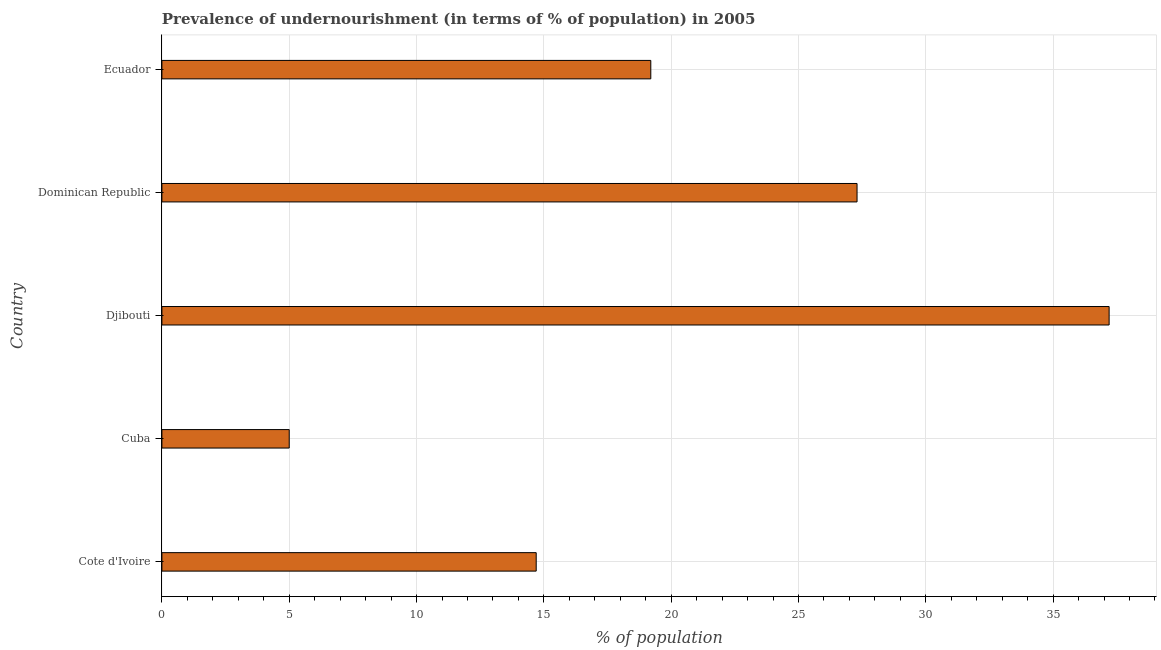Does the graph contain grids?
Provide a short and direct response. Yes. What is the title of the graph?
Keep it short and to the point. Prevalence of undernourishment (in terms of % of population) in 2005. What is the label or title of the X-axis?
Your answer should be compact. % of population. What is the percentage of undernourished population in Ecuador?
Offer a terse response. 19.2. Across all countries, what is the maximum percentage of undernourished population?
Make the answer very short. 37.2. In which country was the percentage of undernourished population maximum?
Provide a short and direct response. Djibouti. In which country was the percentage of undernourished population minimum?
Your response must be concise. Cuba. What is the sum of the percentage of undernourished population?
Keep it short and to the point. 103.4. What is the average percentage of undernourished population per country?
Offer a terse response. 20.68. What is the median percentage of undernourished population?
Provide a succinct answer. 19.2. What is the ratio of the percentage of undernourished population in Cote d'Ivoire to that in Cuba?
Ensure brevity in your answer.  2.94. Is the difference between the percentage of undernourished population in Cote d'Ivoire and Djibouti greater than the difference between any two countries?
Ensure brevity in your answer.  No. What is the difference between the highest and the second highest percentage of undernourished population?
Make the answer very short. 9.9. What is the difference between the highest and the lowest percentage of undernourished population?
Offer a very short reply. 32.2. How many bars are there?
Offer a terse response. 5. What is the difference between two consecutive major ticks on the X-axis?
Your answer should be very brief. 5. What is the % of population of Djibouti?
Make the answer very short. 37.2. What is the % of population in Dominican Republic?
Your answer should be compact. 27.3. What is the difference between the % of population in Cote d'Ivoire and Djibouti?
Your answer should be compact. -22.5. What is the difference between the % of population in Cote d'Ivoire and Dominican Republic?
Offer a very short reply. -12.6. What is the difference between the % of population in Cuba and Djibouti?
Provide a short and direct response. -32.2. What is the difference between the % of population in Cuba and Dominican Republic?
Your response must be concise. -22.3. What is the difference between the % of population in Djibouti and Ecuador?
Provide a short and direct response. 18. What is the ratio of the % of population in Cote d'Ivoire to that in Cuba?
Keep it short and to the point. 2.94. What is the ratio of the % of population in Cote d'Ivoire to that in Djibouti?
Your answer should be compact. 0.4. What is the ratio of the % of population in Cote d'Ivoire to that in Dominican Republic?
Ensure brevity in your answer.  0.54. What is the ratio of the % of population in Cote d'Ivoire to that in Ecuador?
Ensure brevity in your answer.  0.77. What is the ratio of the % of population in Cuba to that in Djibouti?
Your response must be concise. 0.13. What is the ratio of the % of population in Cuba to that in Dominican Republic?
Your answer should be compact. 0.18. What is the ratio of the % of population in Cuba to that in Ecuador?
Give a very brief answer. 0.26. What is the ratio of the % of population in Djibouti to that in Dominican Republic?
Your response must be concise. 1.36. What is the ratio of the % of population in Djibouti to that in Ecuador?
Offer a terse response. 1.94. What is the ratio of the % of population in Dominican Republic to that in Ecuador?
Keep it short and to the point. 1.42. 